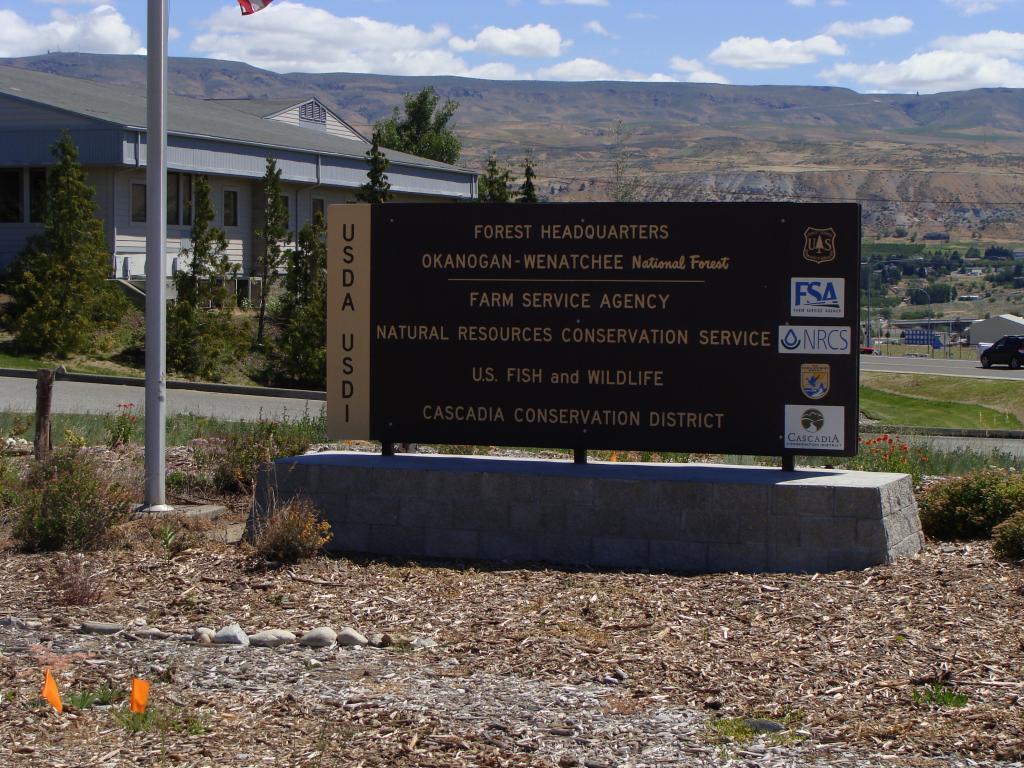Could you give a brief overview of what you see in this image? In this image, there is an outside view. There is a board in the middle of the image. There is a building in the top left of the image. There is a pole on the left side of the image. There is a sky at the top of the image. 